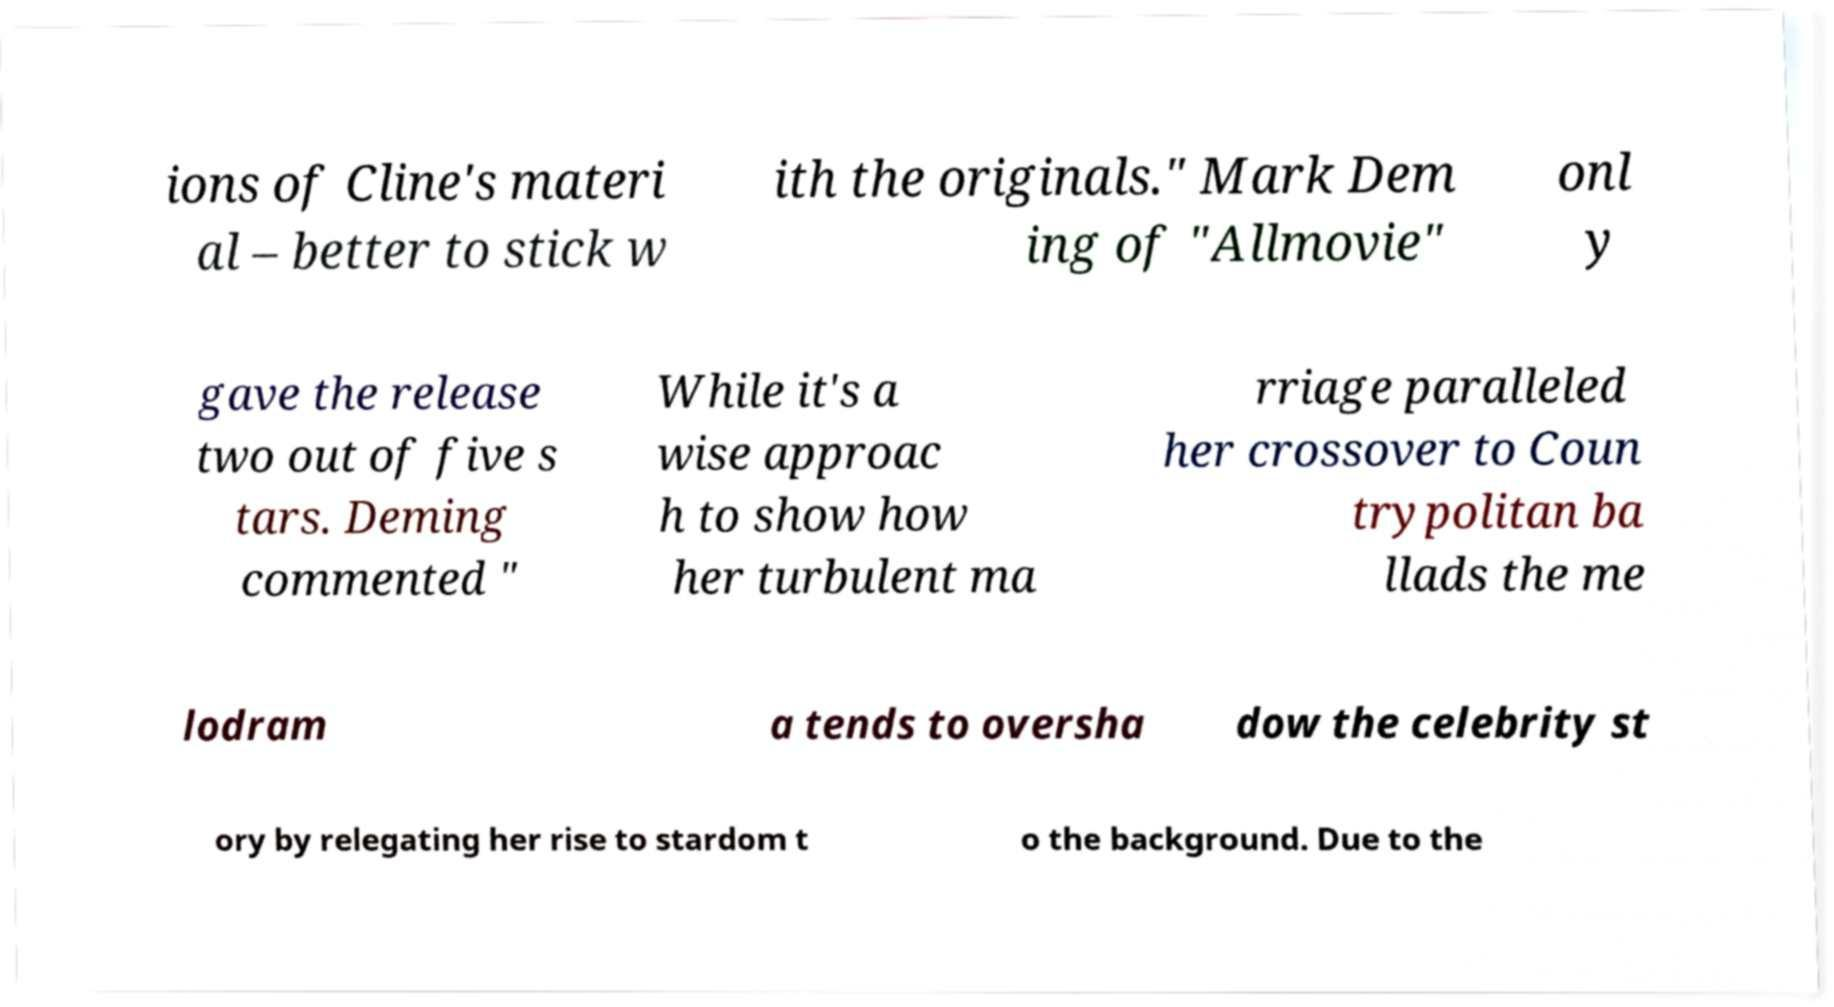Can you accurately transcribe the text from the provided image for me? ions of Cline's materi al – better to stick w ith the originals." Mark Dem ing of "Allmovie" onl y gave the release two out of five s tars. Deming commented " While it's a wise approac h to show how her turbulent ma rriage paralleled her crossover to Coun trypolitan ba llads the me lodram a tends to oversha dow the celebrity st ory by relegating her rise to stardom t o the background. Due to the 